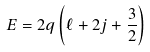Convert formula to latex. <formula><loc_0><loc_0><loc_500><loc_500>E = 2 q \left ( { \ell + 2 j + \frac { 3 } { 2 } } \right )</formula> 